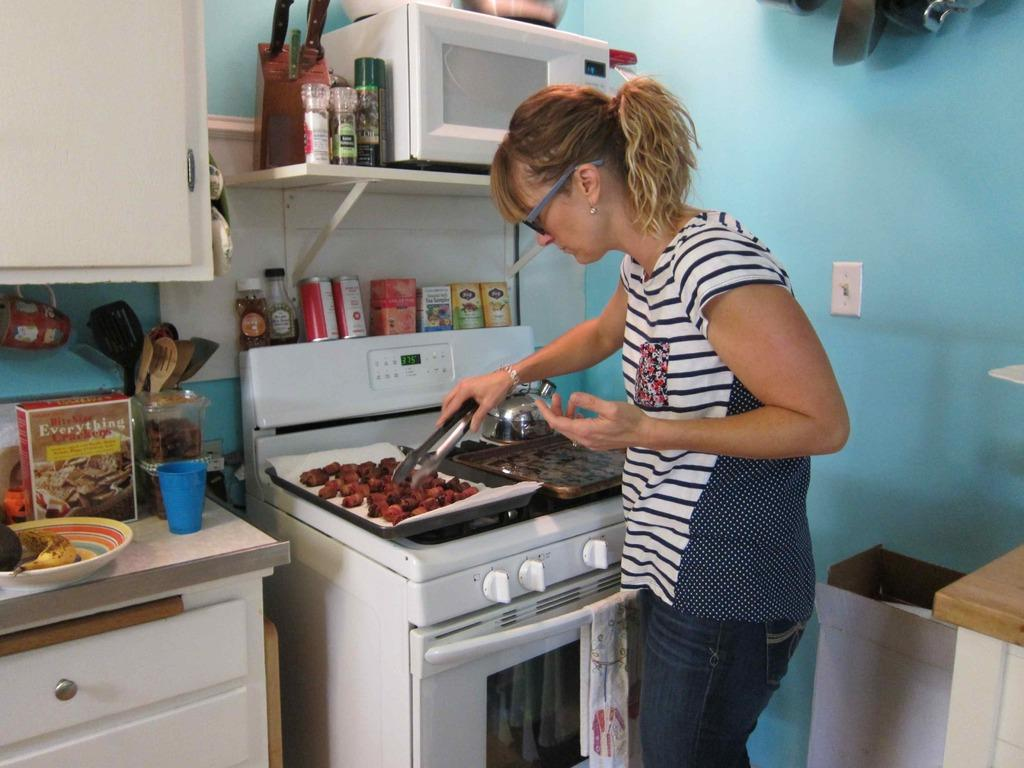<image>
Give a short and clear explanation of the subsequent image. A woman holding tongs over a baking sheet filled with food and a box of "Bite size Everything Crackers" on the counter beside her. 